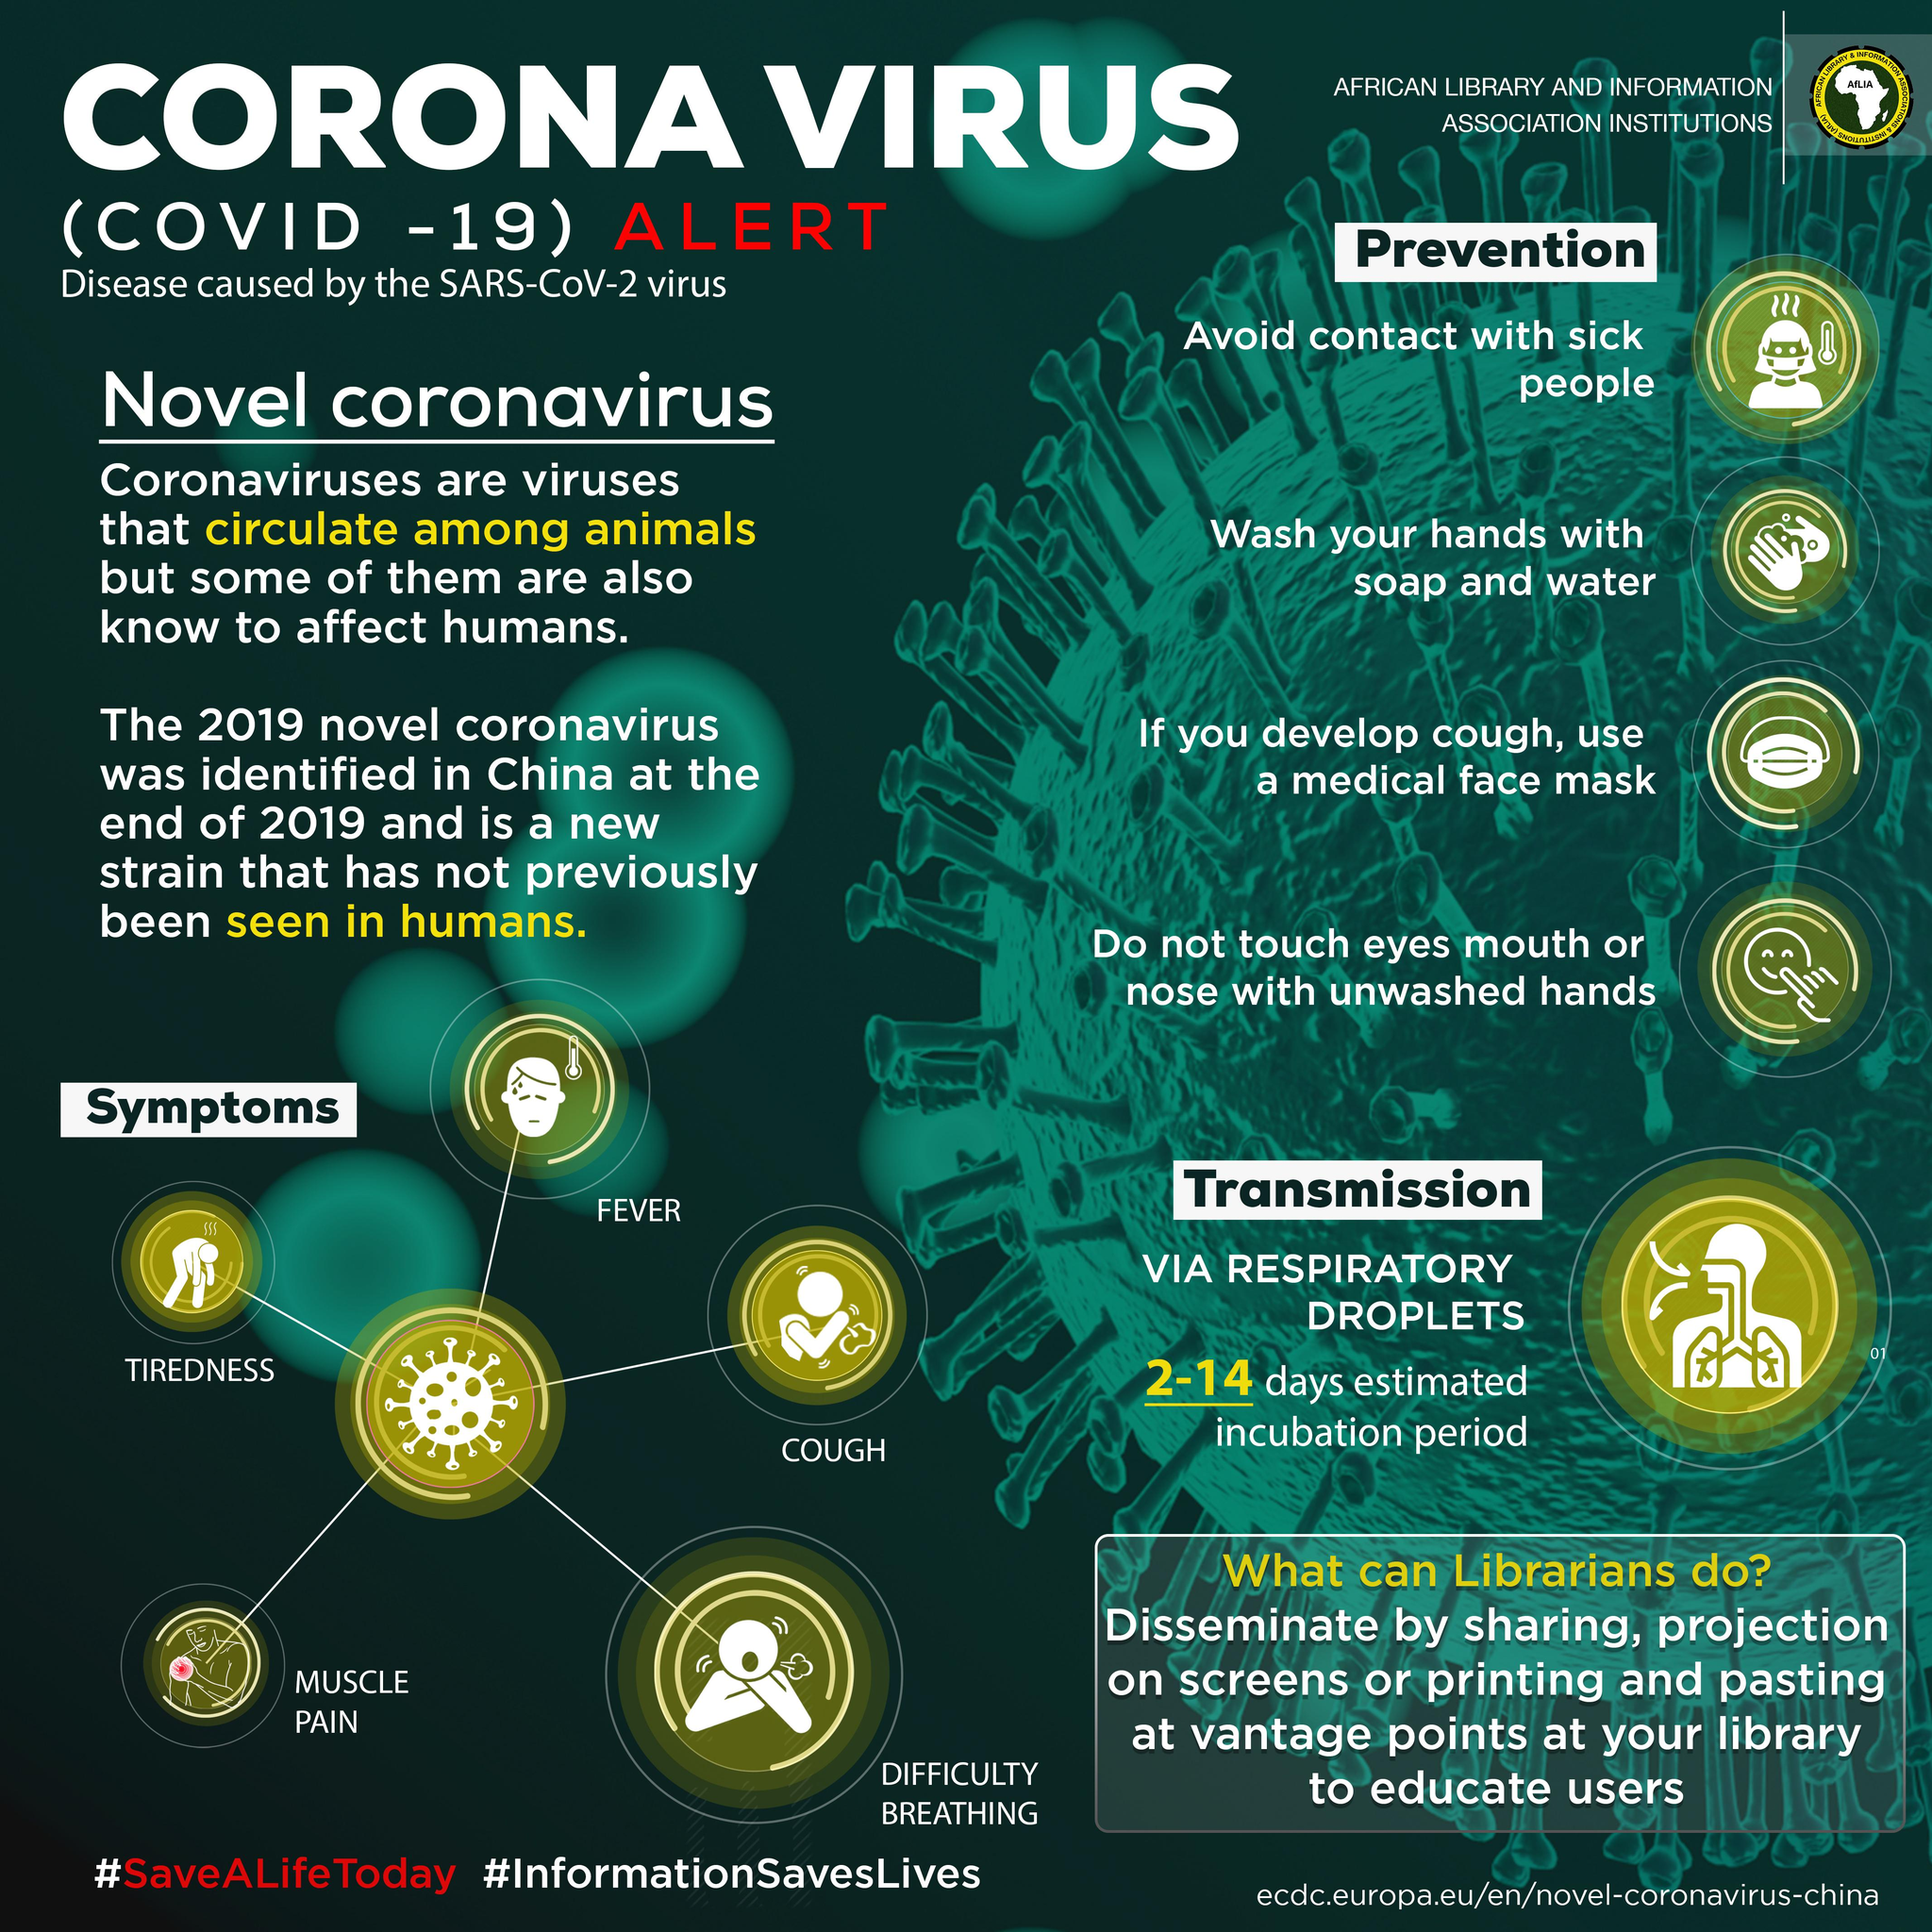Point out several critical features in this image. The incubation period of COVID-19, the virus that causes COVID-19, is typically 2-14 days. COVID-19 can cause a range of symptoms other than the typical cough, fever, and difficulty breathing. These may include fatigue, muscle pain, headache, and gastrointestinal symptoms such as nausea and vomiting. Additionally, COVID-19 can cause symptoms such as changes in mental status, such as confusion or disorientation, and myalgia, or muscle pain. 